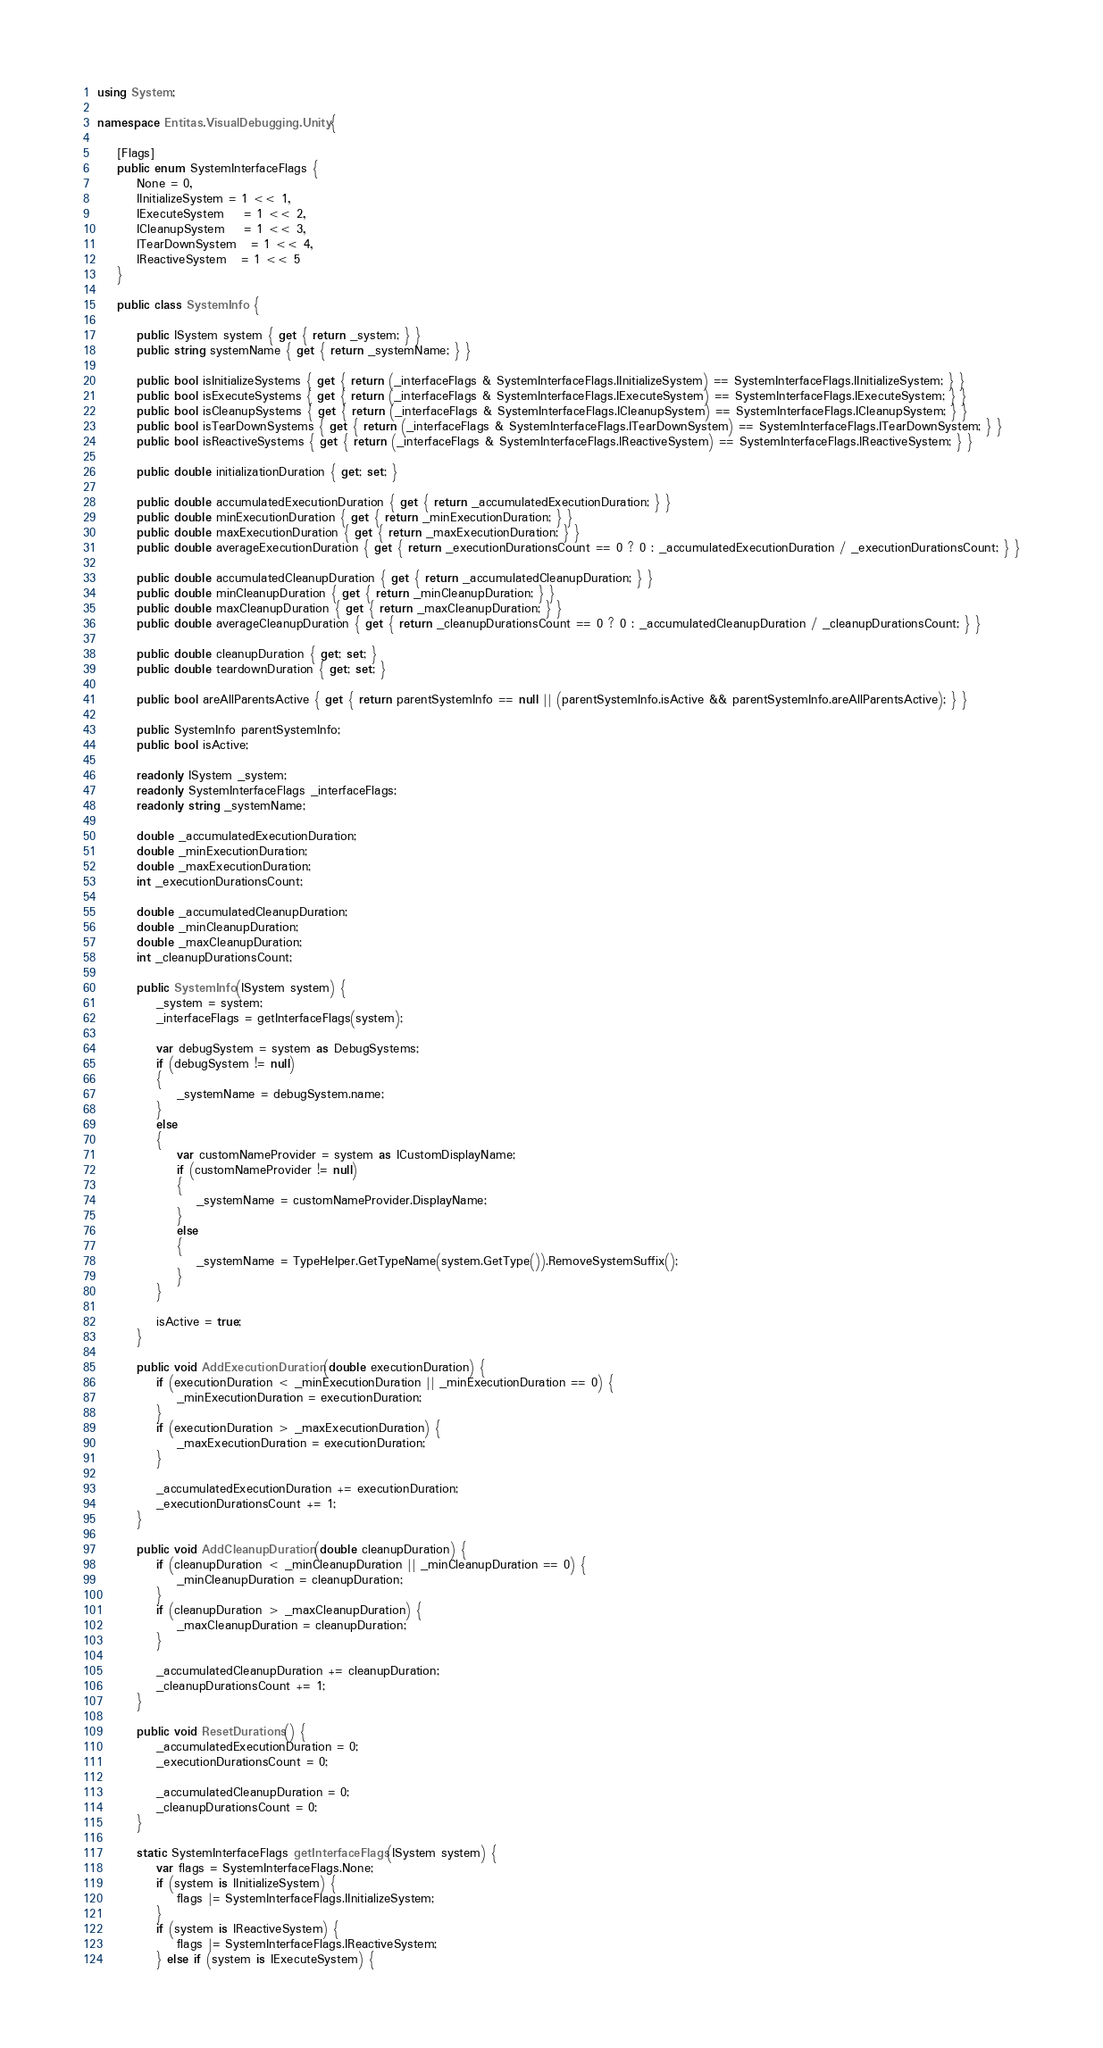<code> <loc_0><loc_0><loc_500><loc_500><_C#_>using System;

namespace Entitas.VisualDebugging.Unity {

    [Flags]
    public enum SystemInterfaceFlags {
        None = 0,
        IInitializeSystem = 1 << 1,
        IExecuteSystem    = 1 << 2,
        ICleanupSystem    = 1 << 3,
        ITearDownSystem   = 1 << 4,
        IReactiveSystem   = 1 << 5
    }

    public class SystemInfo {

        public ISystem system { get { return _system; } }
        public string systemName { get { return _systemName; } }

        public bool isInitializeSystems { get { return (_interfaceFlags & SystemInterfaceFlags.IInitializeSystem) == SystemInterfaceFlags.IInitializeSystem; } }
        public bool isExecuteSystems { get { return (_interfaceFlags & SystemInterfaceFlags.IExecuteSystem) == SystemInterfaceFlags.IExecuteSystem; } }
        public bool isCleanupSystems { get { return (_interfaceFlags & SystemInterfaceFlags.ICleanupSystem) == SystemInterfaceFlags.ICleanupSystem; } }
        public bool isTearDownSystems { get { return (_interfaceFlags & SystemInterfaceFlags.ITearDownSystem) == SystemInterfaceFlags.ITearDownSystem; } }
        public bool isReactiveSystems { get { return (_interfaceFlags & SystemInterfaceFlags.IReactiveSystem) == SystemInterfaceFlags.IReactiveSystem; } }

        public double initializationDuration { get; set; }

        public double accumulatedExecutionDuration { get { return _accumulatedExecutionDuration; } }
        public double minExecutionDuration { get { return _minExecutionDuration; } }
        public double maxExecutionDuration { get { return _maxExecutionDuration; } }
        public double averageExecutionDuration { get { return _executionDurationsCount == 0 ? 0 : _accumulatedExecutionDuration / _executionDurationsCount; } }

        public double accumulatedCleanupDuration { get { return _accumulatedCleanupDuration; } }
        public double minCleanupDuration { get { return _minCleanupDuration; } }
        public double maxCleanupDuration { get { return _maxCleanupDuration; } }
        public double averageCleanupDuration { get { return _cleanupDurationsCount == 0 ? 0 : _accumulatedCleanupDuration / _cleanupDurationsCount; } }

        public double cleanupDuration { get; set; }
        public double teardownDuration { get; set; }

        public bool areAllParentsActive { get { return parentSystemInfo == null || (parentSystemInfo.isActive && parentSystemInfo.areAllParentsActive); } }

        public SystemInfo parentSystemInfo;
        public bool isActive;

        readonly ISystem _system;
        readonly SystemInterfaceFlags _interfaceFlags;
        readonly string _systemName;

        double _accumulatedExecutionDuration;
        double _minExecutionDuration;
        double _maxExecutionDuration;
        int _executionDurationsCount;

        double _accumulatedCleanupDuration;
        double _minCleanupDuration;
        double _maxCleanupDuration;
        int _cleanupDurationsCount;

        public SystemInfo(ISystem system) {
            _system = system;
            _interfaceFlags = getInterfaceFlags(system);

            var debugSystem = system as DebugSystems;
            if (debugSystem != null)
            {
                _systemName = debugSystem.name;
            }
            else
            {
                var customNameProvider = system as ICustomDisplayName;
                if (customNameProvider != null)
                {
                    _systemName = customNameProvider.DisplayName;
                }
                else
                {
                    _systemName = TypeHelper.GetTypeName(system.GetType()).RemoveSystemSuffix();
                }
            }

            isActive = true;
        }

        public void AddExecutionDuration(double executionDuration) {
            if (executionDuration < _minExecutionDuration || _minExecutionDuration == 0) {
                _minExecutionDuration = executionDuration;
            }
            if (executionDuration > _maxExecutionDuration) {
                _maxExecutionDuration = executionDuration;
            }

            _accumulatedExecutionDuration += executionDuration;
            _executionDurationsCount += 1;
        }

        public void AddCleanupDuration(double cleanupDuration) {
            if (cleanupDuration < _minCleanupDuration || _minCleanupDuration == 0) {
                _minCleanupDuration = cleanupDuration;
            }
            if (cleanupDuration > _maxCleanupDuration) {
                _maxCleanupDuration = cleanupDuration;
            }

            _accumulatedCleanupDuration += cleanupDuration;
            _cleanupDurationsCount += 1;
        }

        public void ResetDurations() {
            _accumulatedExecutionDuration = 0;
            _executionDurationsCount = 0;

            _accumulatedCleanupDuration = 0;
            _cleanupDurationsCount = 0;
        }

        static SystemInterfaceFlags getInterfaceFlags(ISystem system) {
            var flags = SystemInterfaceFlags.None;
            if (system is IInitializeSystem) {
                flags |= SystemInterfaceFlags.IInitializeSystem;
            }
            if (system is IReactiveSystem) {
                flags |= SystemInterfaceFlags.IReactiveSystem;
            } else if (system is IExecuteSystem) {</code> 